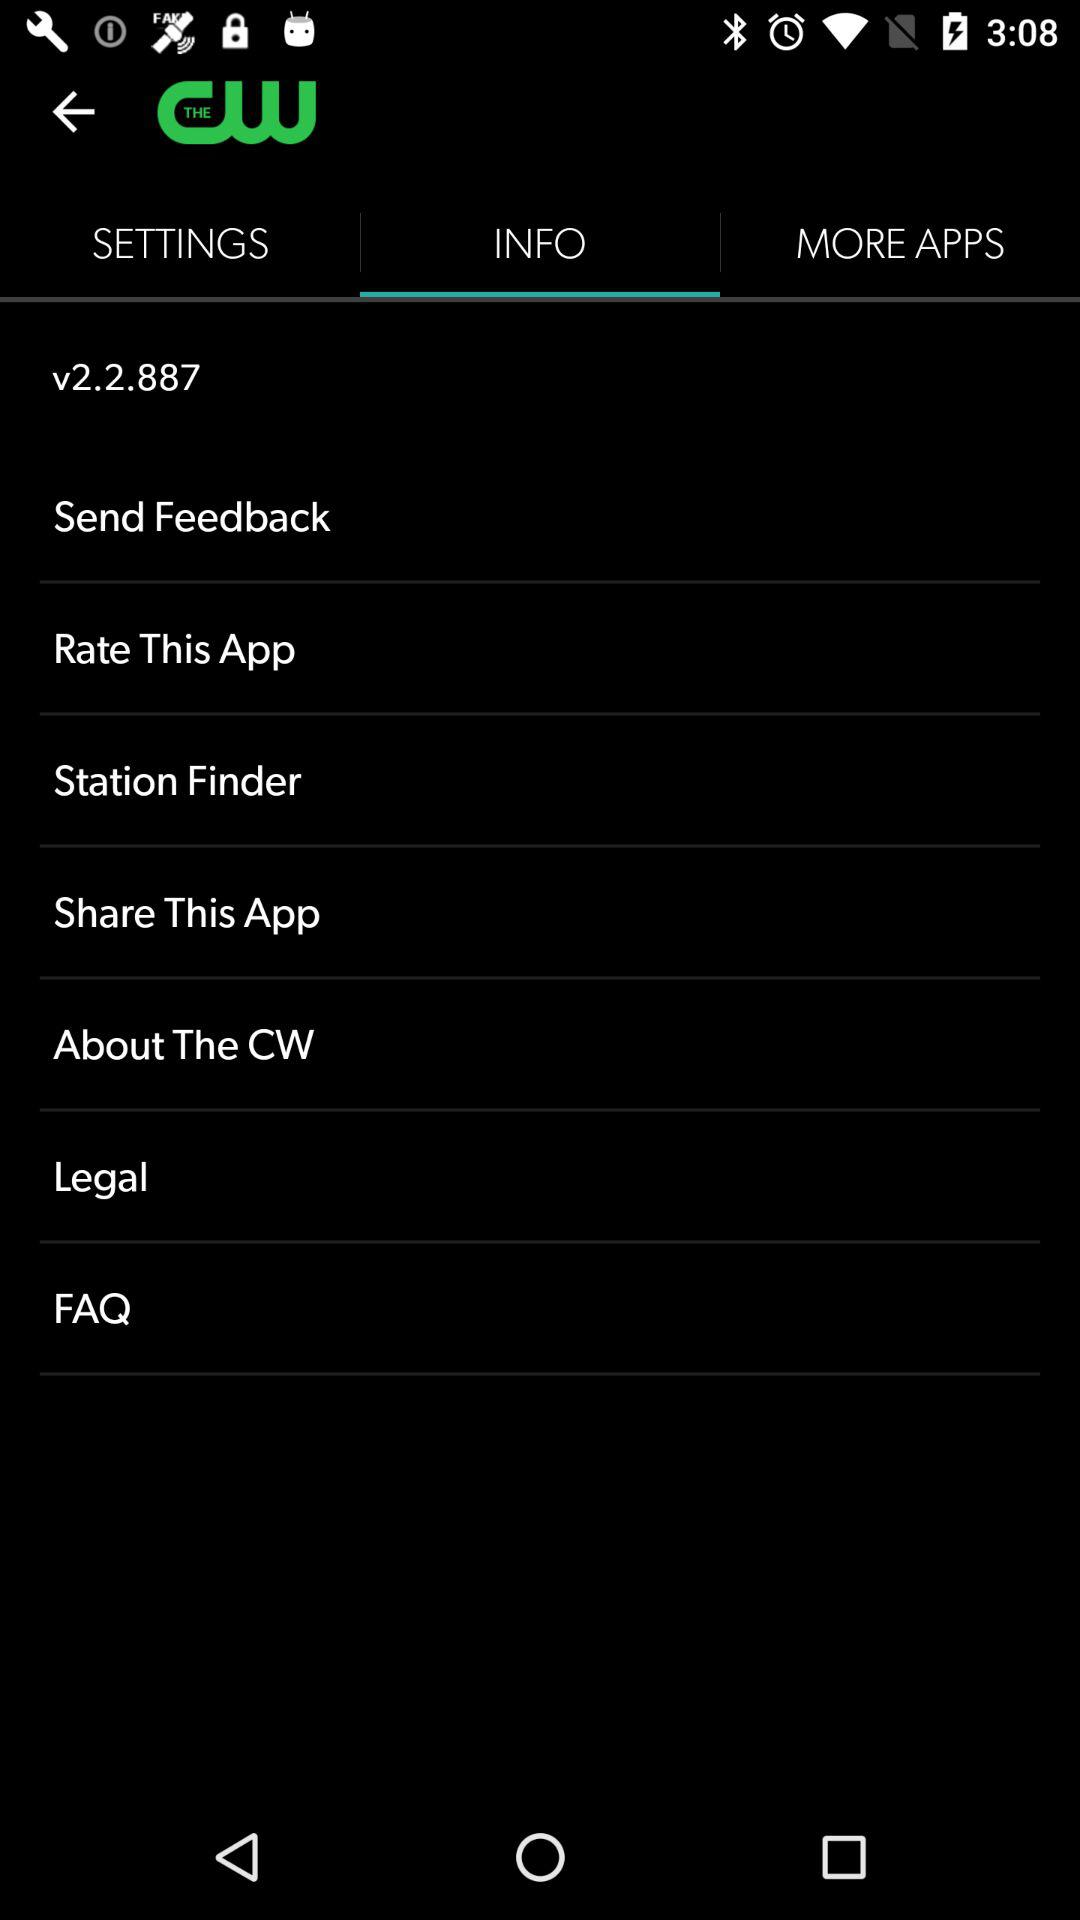When was version 2.2.887 updated?
When the provided information is insufficient, respond with <no answer>. <no answer> 